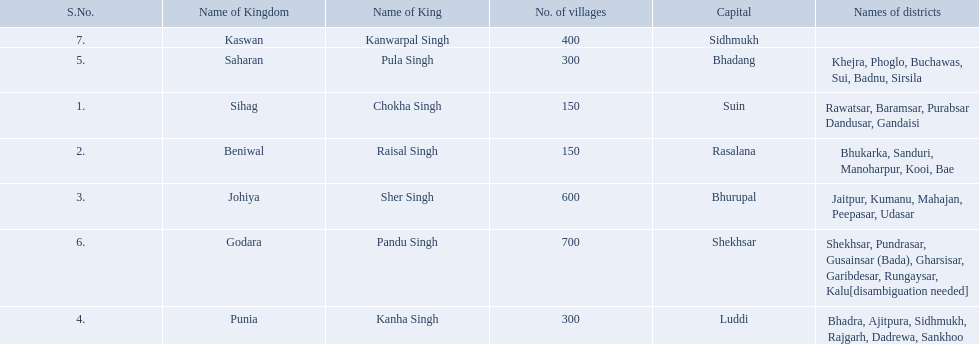Which kingdom contained the least amount of villages along with sihag? Beniwal. Which kingdom contained the most villages? Godara. Which village was tied at second most villages with godara? Johiya. 